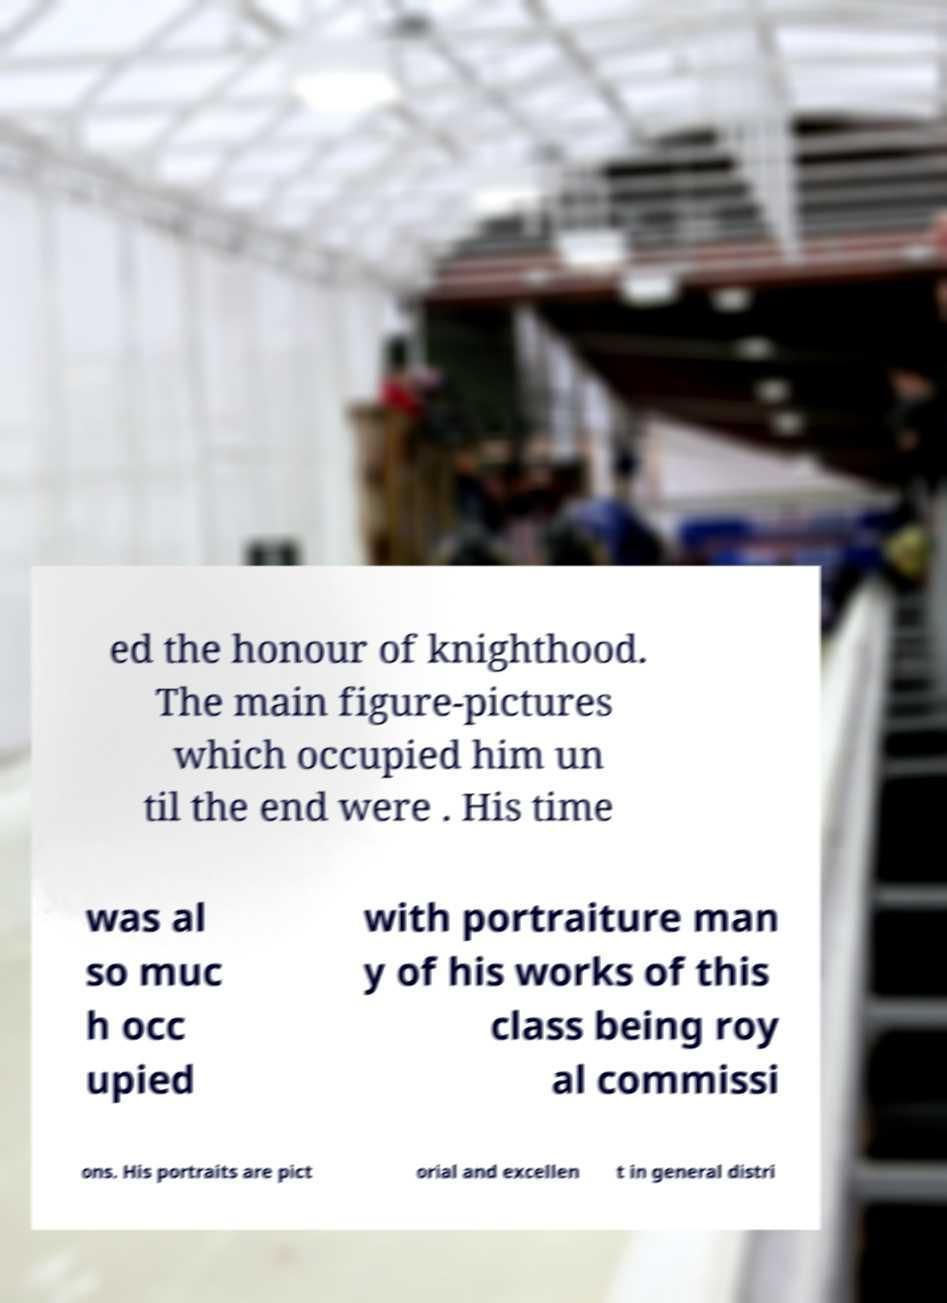Can you read and provide the text displayed in the image?This photo seems to have some interesting text. Can you extract and type it out for me? ed the honour of knighthood. The main figure-pictures which occupied him un til the end were . His time was al so muc h occ upied with portraiture man y of his works of this class being roy al commissi ons. His portraits are pict orial and excellen t in general distri 